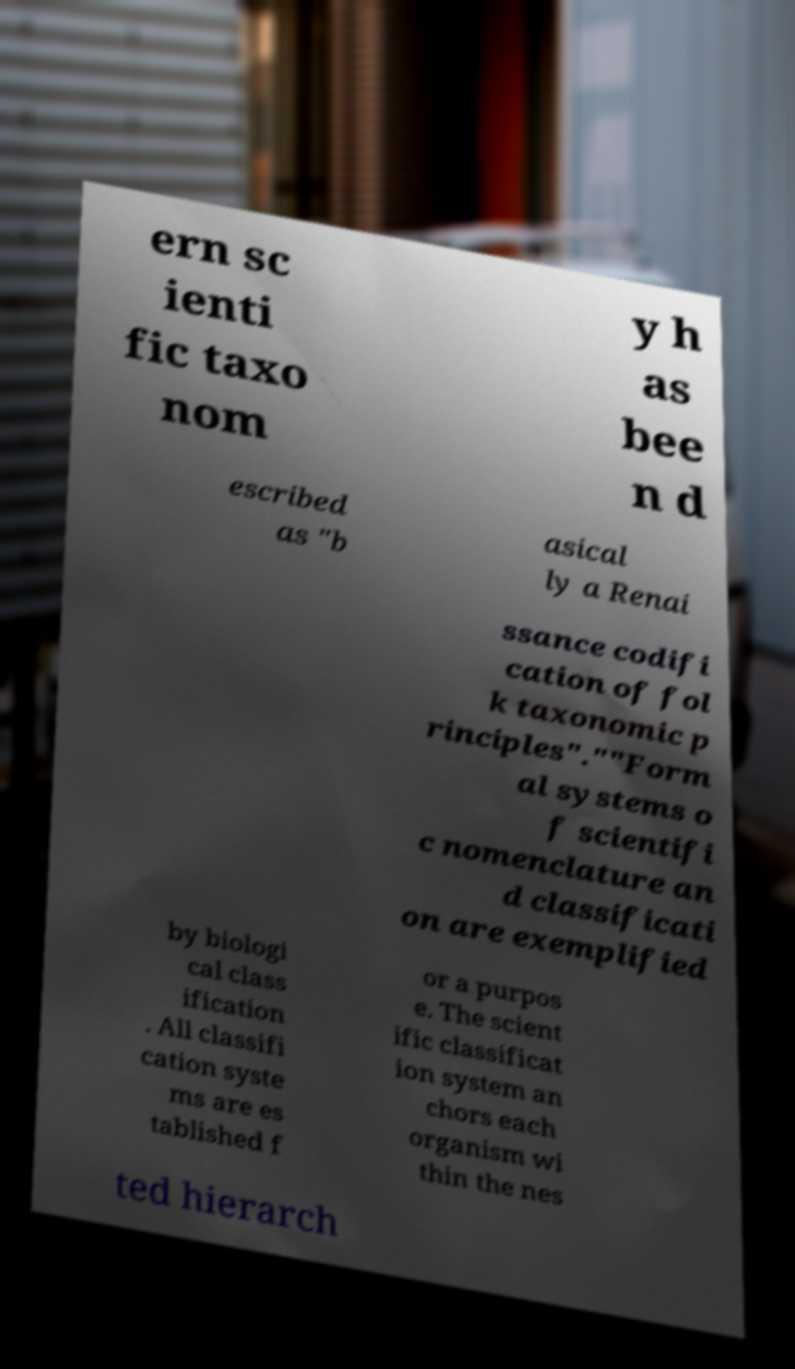I need the written content from this picture converted into text. Can you do that? ern sc ienti fic taxo nom y h as bee n d escribed as "b asical ly a Renai ssance codifi cation of fol k taxonomic p rinciples".""Form al systems o f scientifi c nomenclature an d classificati on are exemplified by biologi cal class ification . All classifi cation syste ms are es tablished f or a purpos e. The scient ific classificat ion system an chors each organism wi thin the nes ted hierarch 